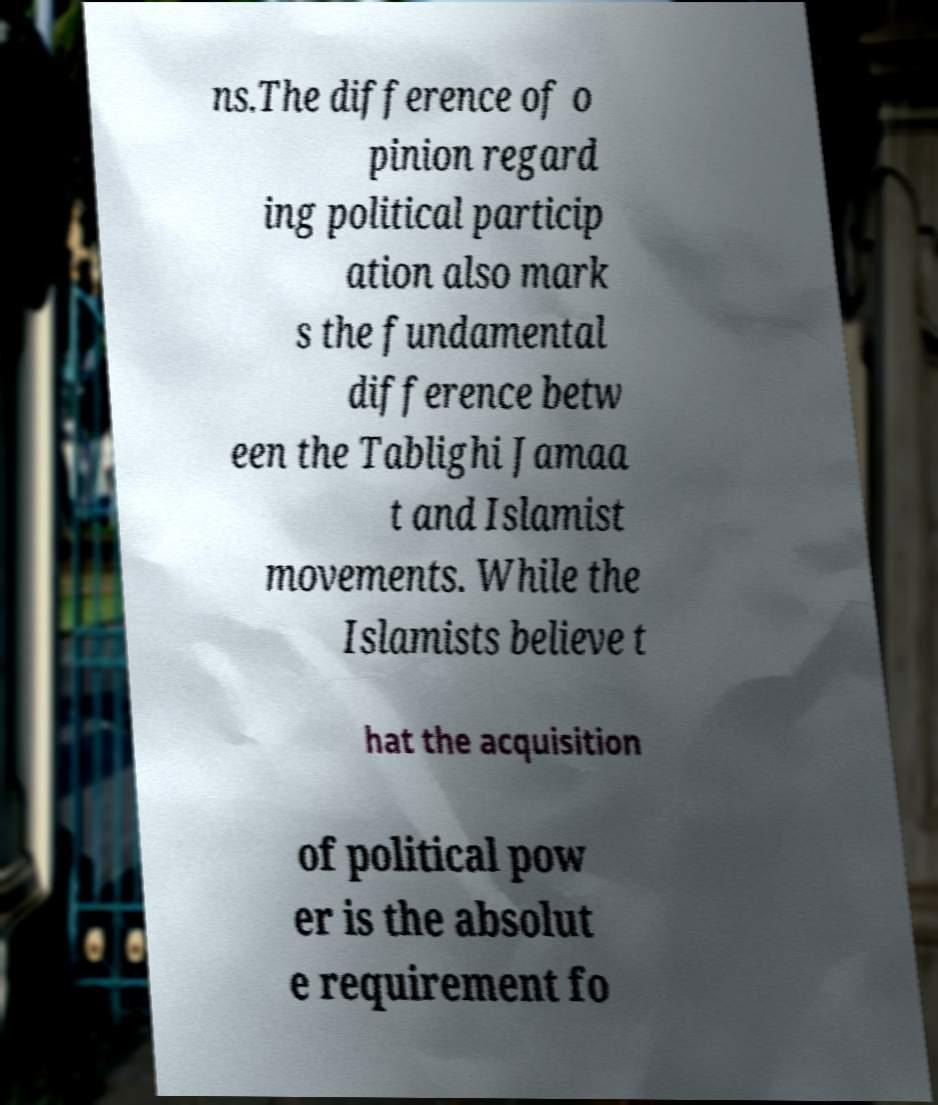Can you read and provide the text displayed in the image?This photo seems to have some interesting text. Can you extract and type it out for me? ns.The difference of o pinion regard ing political particip ation also mark s the fundamental difference betw een the Tablighi Jamaa t and Islamist movements. While the Islamists believe t hat the acquisition of political pow er is the absolut e requirement fo 